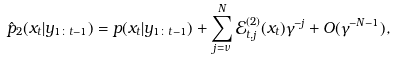Convert formula to latex. <formula><loc_0><loc_0><loc_500><loc_500>\hat { p } _ { 2 } ( x _ { t } | y _ { 1 \colon t - 1 } ) = p ( x _ { t } | y _ { 1 \colon t - 1 } ) + \sum _ { j = \nu } ^ { N } \mathcal { E } ^ { ( 2 ) } _ { t , j } ( x _ { t } ) \gamma ^ { - j } + O ( \gamma ^ { - N - 1 } ) ,</formula> 